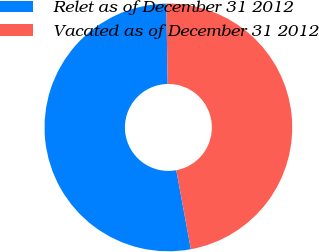Convert chart to OTSL. <chart><loc_0><loc_0><loc_500><loc_500><pie_chart><fcel>Relet as of December 31 2012<fcel>Vacated as of December 31 2012<nl><fcel>52.64%<fcel>47.36%<nl></chart> 